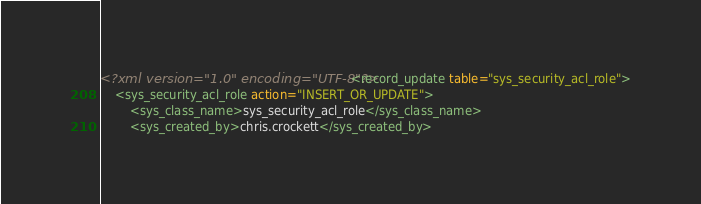Convert code to text. <code><loc_0><loc_0><loc_500><loc_500><_XML_><?xml version="1.0" encoding="UTF-8"?><record_update table="sys_security_acl_role">
    <sys_security_acl_role action="INSERT_OR_UPDATE">
        <sys_class_name>sys_security_acl_role</sys_class_name>
        <sys_created_by>chris.crockett</sys_created_by></code> 